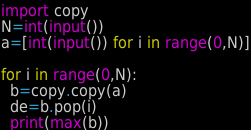<code> <loc_0><loc_0><loc_500><loc_500><_Python_>import copy
N=int(input())
a=[int(input()) for i in range(0,N)]

for i in range(0,N):
  b=copy.copy(a)
  de=b.pop(i)
  print(max(b))</code> 